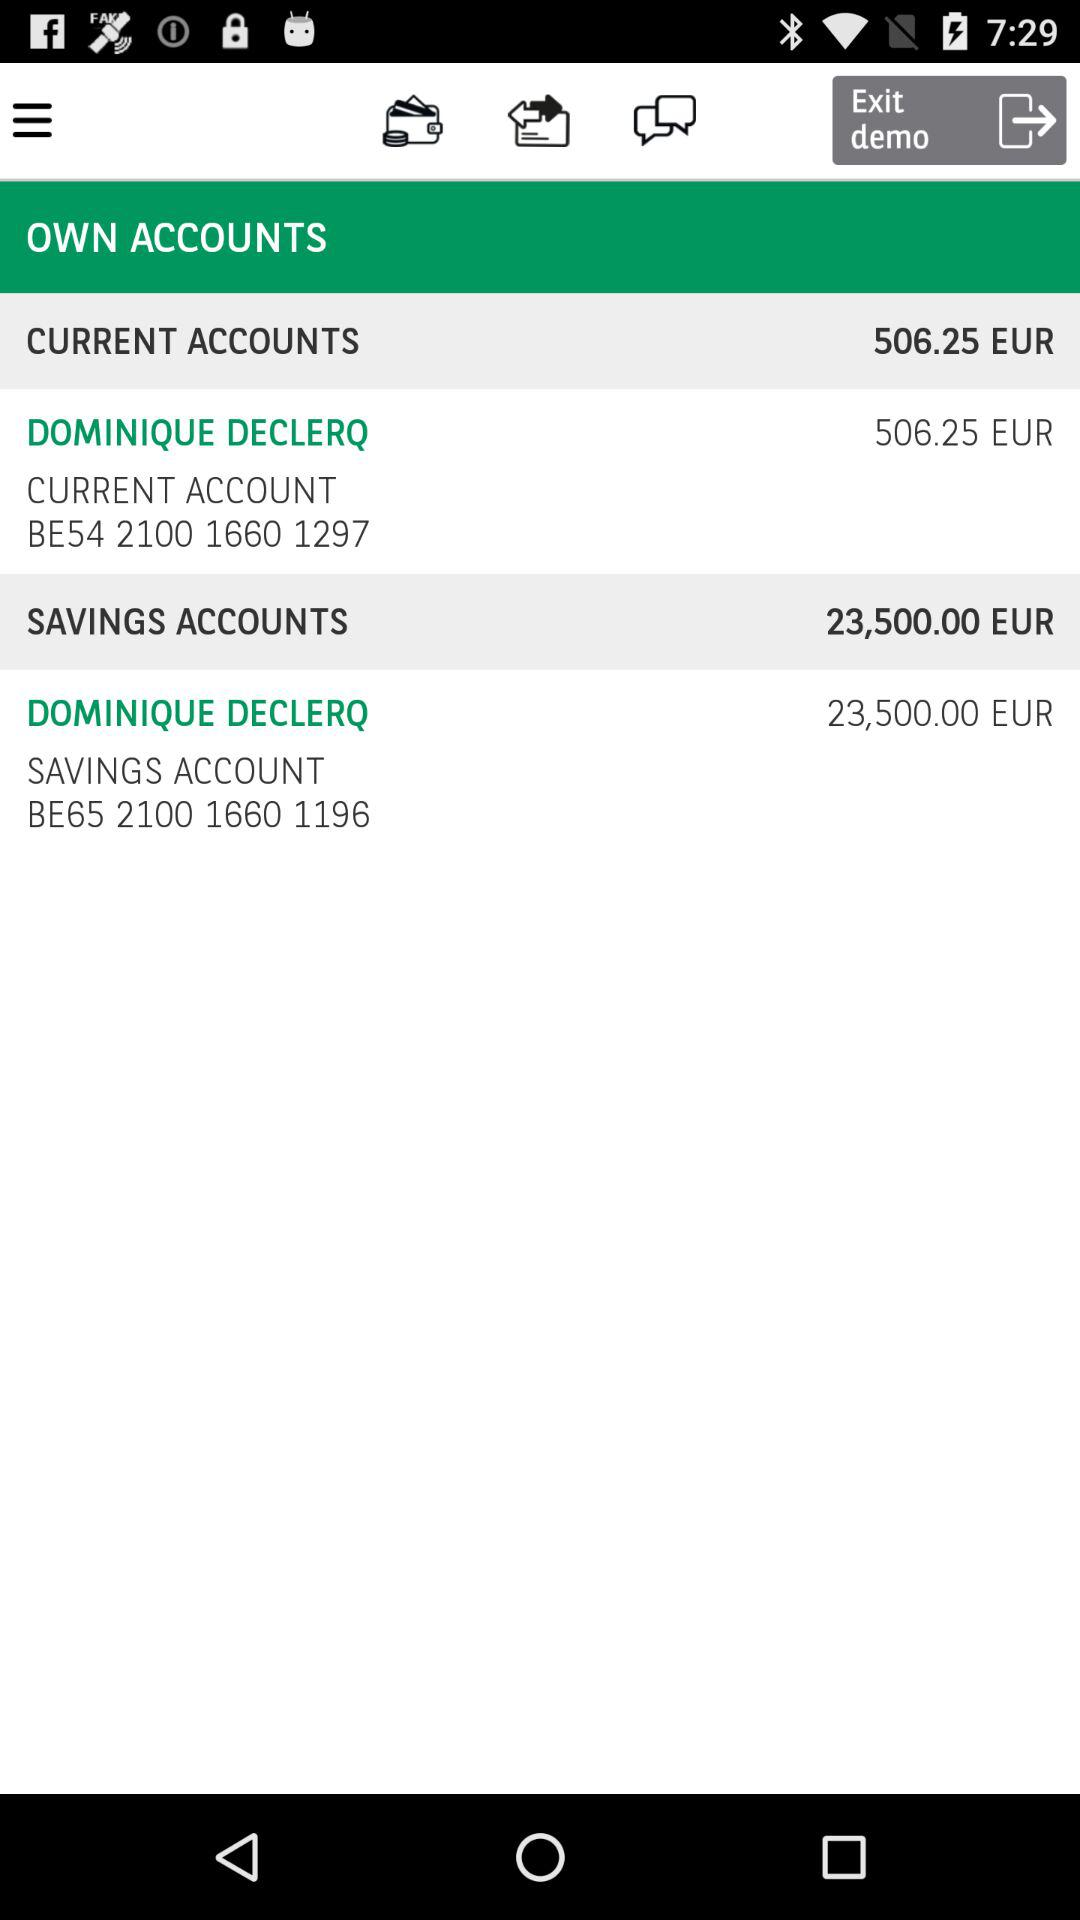What's the currency of amount? The used currency is euros. 